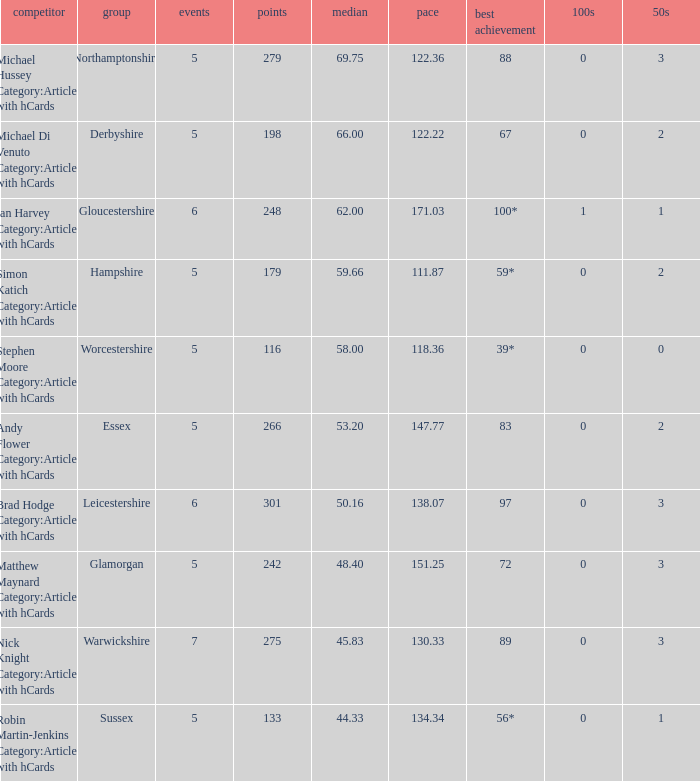If the team is Worcestershire and the Matched had were 5, what is the highest score? 39*. 